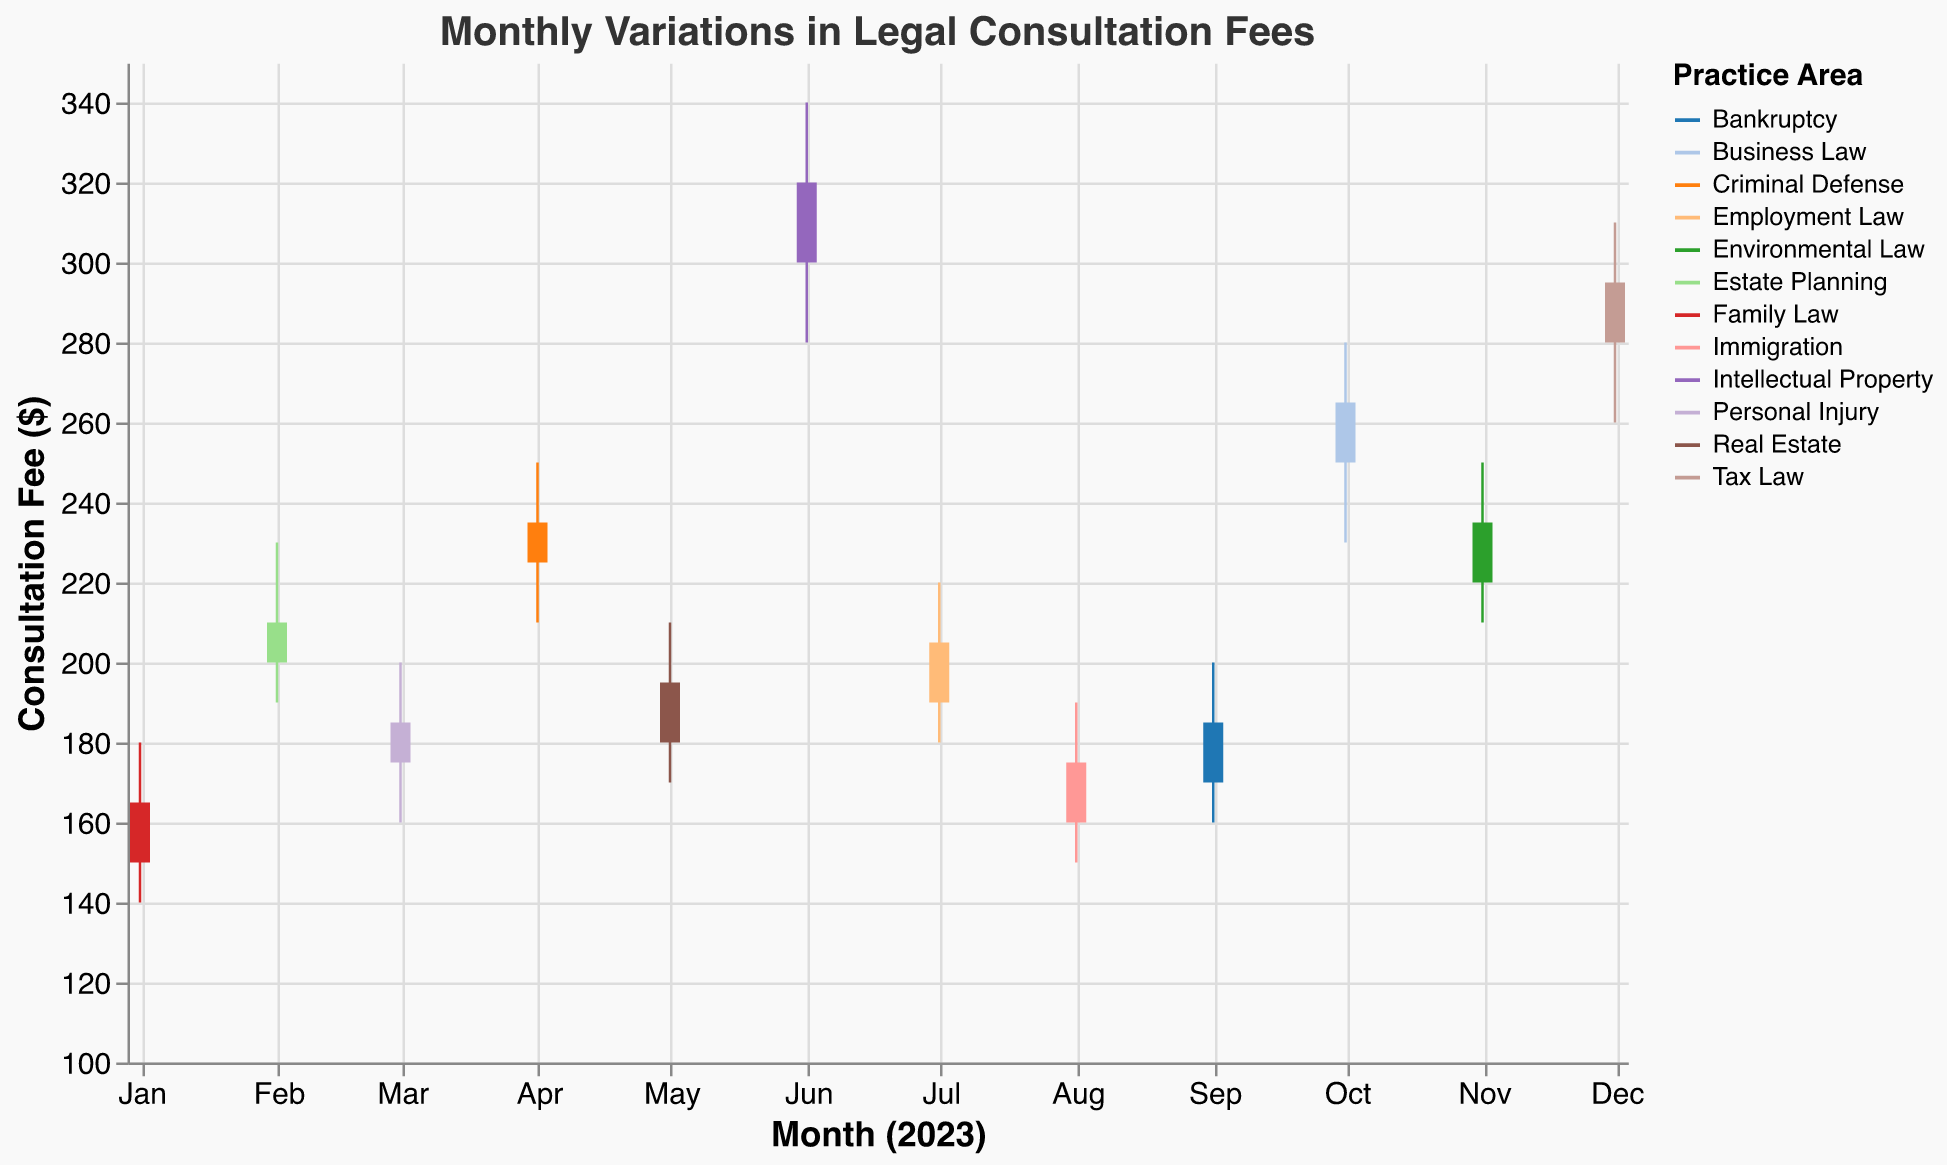What is the highest consultation fee for Intellectual Property in June 2023? The chart shows a bar for Intellectual Property in June 2023, with a top rule indicating the highest fee. Observing this value shows the maximum consultation fee.
Answer: $340 For which month is the closing fee the same for both Criminal Defense and Environmental Law? Look for bars with the same closing fee value for both Criminal Defense and Environmental Law. Both bars close at the same level.
Answer: November Which practice area has the lowest fee recorded and in which month? Identify the lowest 'Low' point on the chart, then check which practice area and month it corresponds to. The lowest fee across all bars and rules corresponds to a specific practice area and month.
Answer: Family Law in January Which practice area closes the year 2023 with the highest consultation fee? The chart lists multiple practice areas, each represented by a bar in December 2023. The practice area with the highest closing value in December is indicated.
Answer: Tax Law What is the average closing fee for the first quarter of 2023 for all practice areas? Sum the closing fees for January, February, and March, then divide by the number of months (three). The bars' closing levels for these three months are summed and averaged.
Answer: $186.67 Which month shows the highest fluctuation in consultation fees for any practice area? Find the largest difference between 'High' and 'Low' values by comparing the length of the rules for each month. The longest vertical distance represents the highest fluctuation.
Answer: June Which practice area had a higher closing fee in July than Immigration in August? Compare the closing fee values for Employment Law in July and Immigration in August. Check bars labeled "July 2023" and "August 2023" and see which has a higher closing level.
Answer: Employment Law Which month has the most significant increase in consultation fees for Bankruptcy? Compare the ‘Open’ and ‘Close’ values for Bankruptcy across months. The month where the `Close` is much higher than the `Open` indicates the most significant fee increase.
Answer: September What is the difference between the highest closing fee and the lowest closing fee recorded during the year? Identify the highest and lowest 'Close' values for all practice areas across months. Subtract the smallest from the largest to find the difference.
Answer: $260 